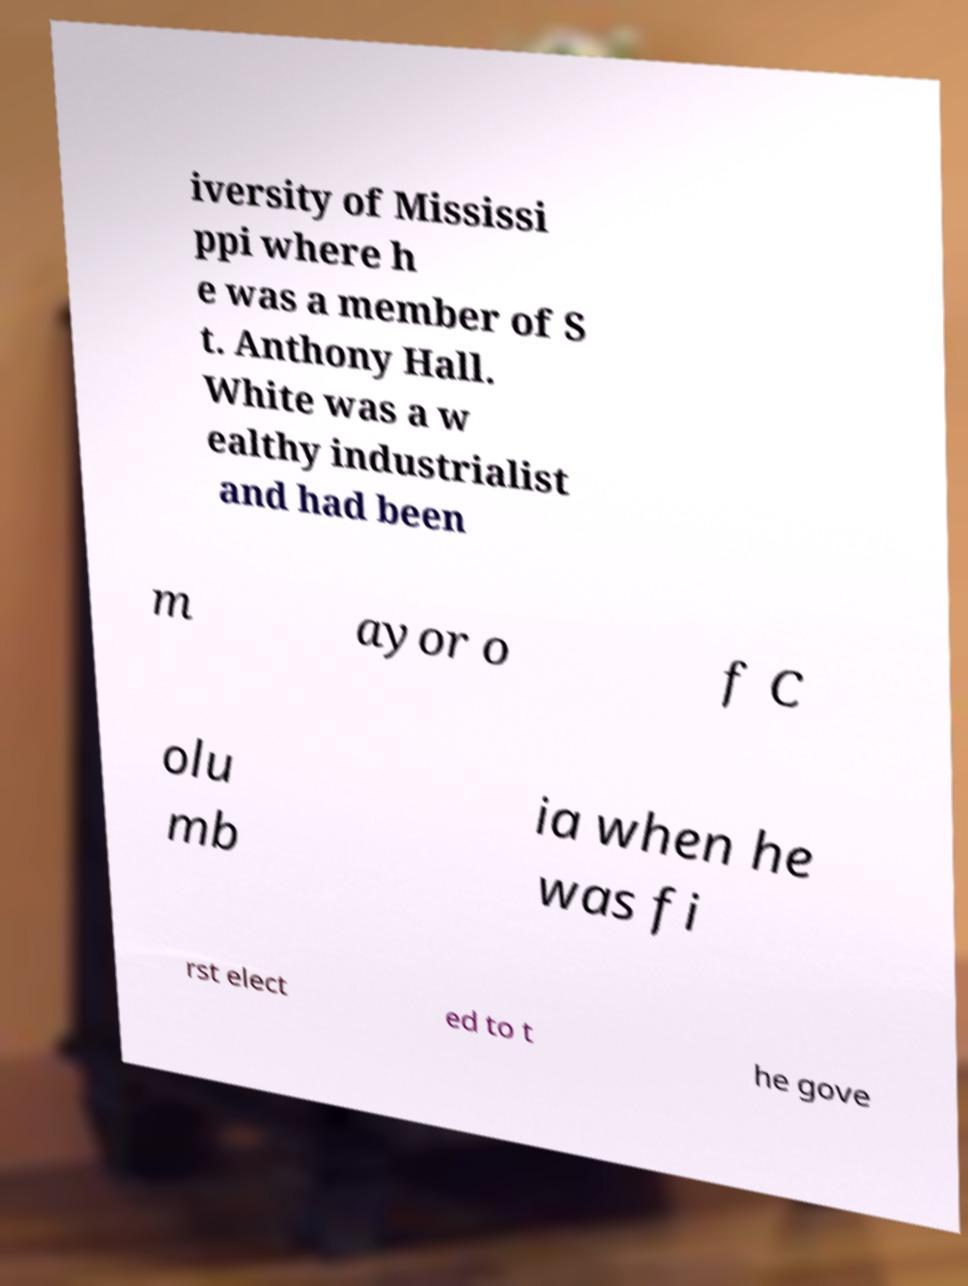Could you assist in decoding the text presented in this image and type it out clearly? iversity of Mississi ppi where h e was a member of S t. Anthony Hall. White was a w ealthy industrialist and had been m ayor o f C olu mb ia when he was fi rst elect ed to t he gove 